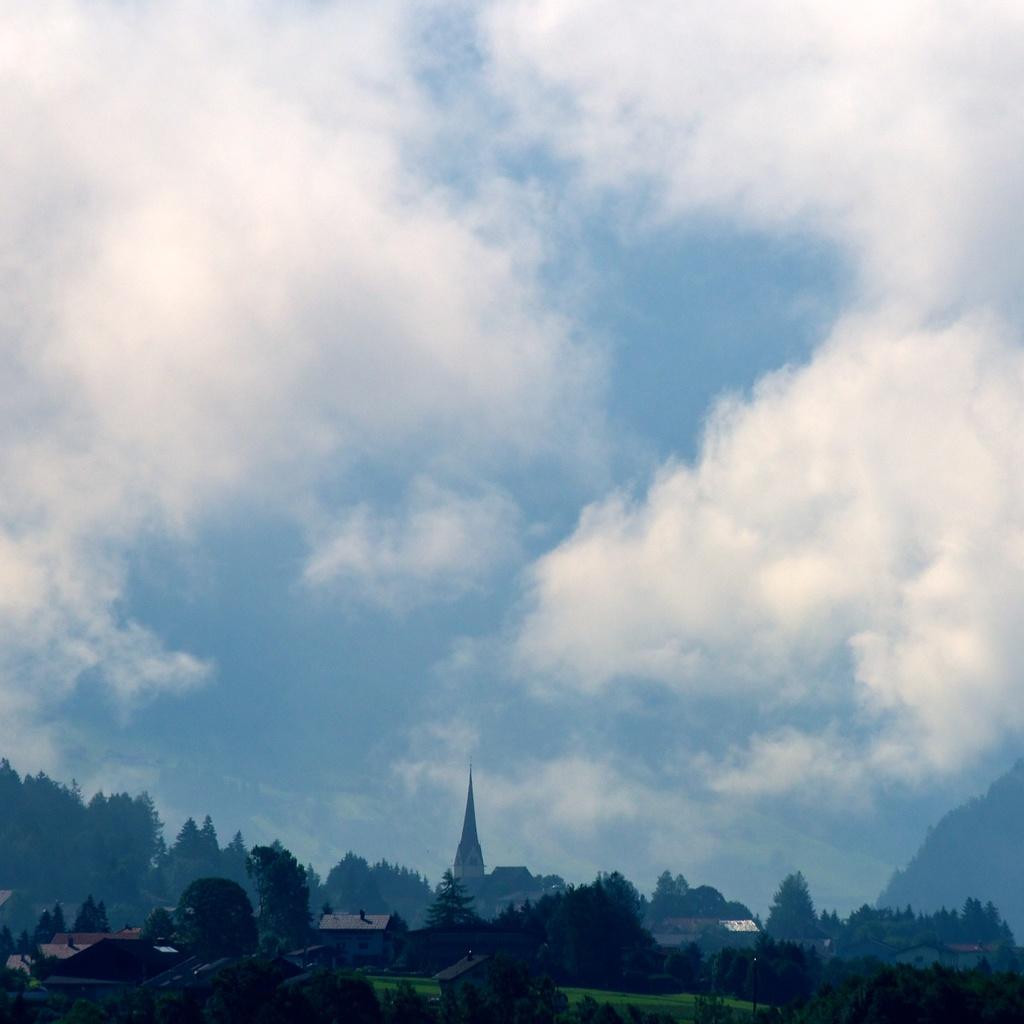Can you describe this image briefly? In this image there are few buildings, trees, grass and some clouds in the sky. 